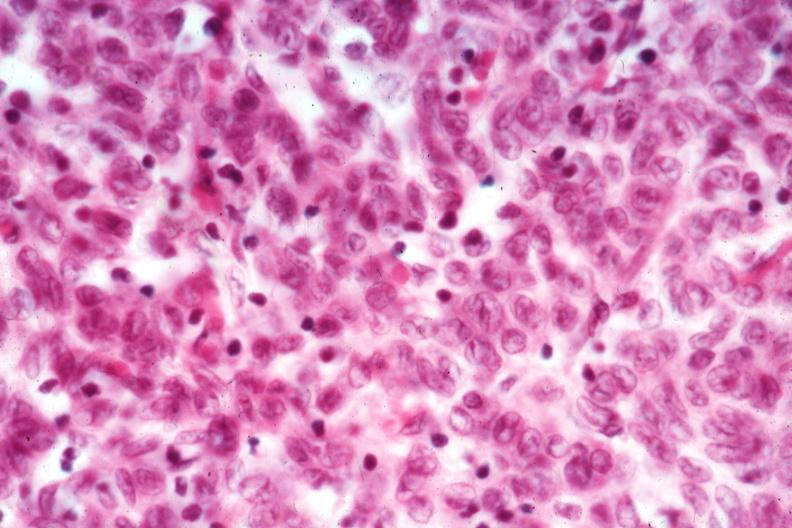s hematologic present?
Answer the question using a single word or phrase. Yes 